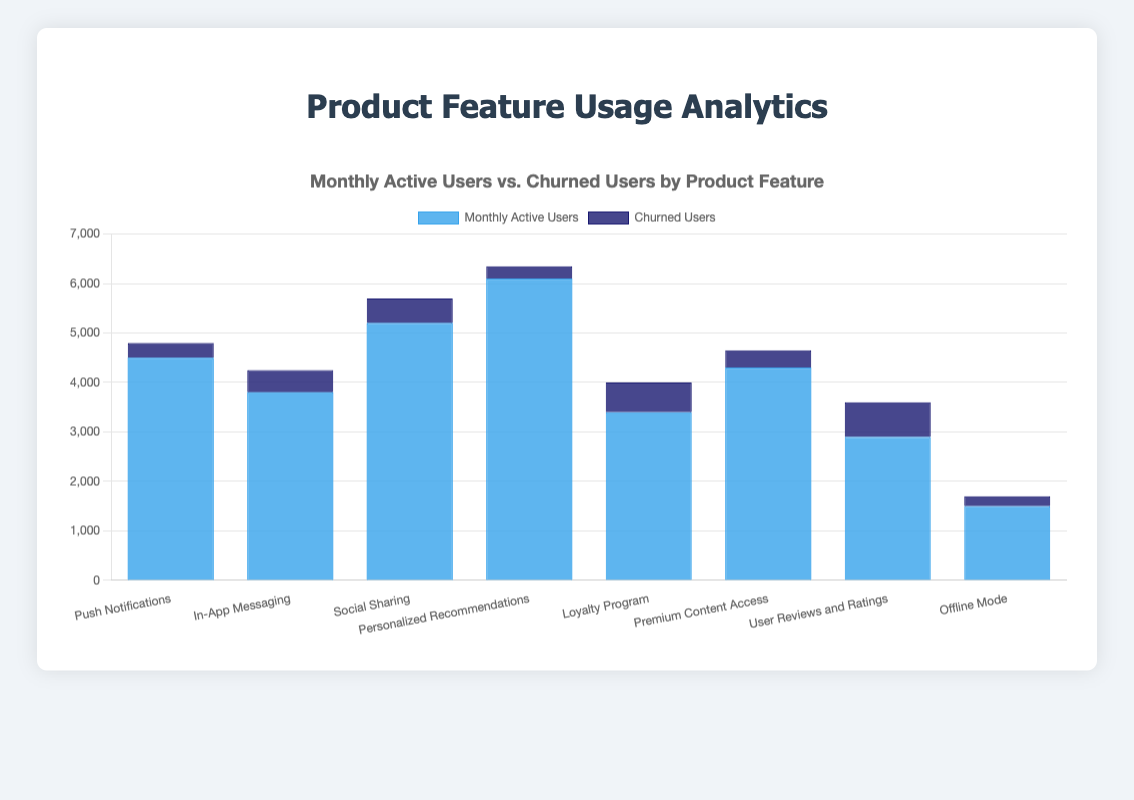Which feature has the highest number of Monthly Active Users? The feature with the highest bar in the dataset is Personalized Recommendations, which has 6,100 Monthly Active Users.
Answer: Personalized Recommendations What is the difference in Monthly Active Users between Social Sharing and In-App Messaging? Social Sharing has 5,200 Monthly Active Users and In-App Messaging has 3,800. The difference is 5,200 - 3,800 = 1,400.
Answer: 1,400 Which feature has the lowest churn rate? (Churn rate = Churned Users / Monthly Active Users) To find the churn rate, calculate the ratio for each feature and compare. Personalized Recommendations has 250 churned users and 6,100 active users, 250/6100 ≈ 0.041 (4.1%), which is the lowest among all features.
Answer: Personalized Recommendations How many features have more than 400 churned users? By observing the data, In-App Messaging (450), Social Sharing (500), Loyalty Program (600), and User Reviews and Ratings (700) have more than 400 churned users. There are 4 features in total.
Answer: 4 Which feature has the highest churn rate? To find the highest churn rate, calculate the ratio for each feature and compare. User Reviews and Ratings has 700 churned users and 2,900 active users, 700/2900 ≈ 0.241 (24.1%), which is the highest among all features.
Answer: User Reviews and Ratings What is the total number of Monthly Active Users across all features? Sum of Monthly Active Users: 4500 + 3800 + 5200 + 6100 + 3400 + 4300 + 2900 + 1500 = 31,700.
Answer: 31,700 Compare the churned users of Push Notifications and Premium Content Access, which has more? Push Notifications has 300 churned users, and Premium Content Access has 350 churned users, so Premium Content Access has more churned users.
Answer: Premium Content Access What is the average number of Monthly Active Users per feature? Sum of Monthly Active Users is 31,700. There are 8 features, so the average is 31,700 / 8 = 3,962.5.
Answer: 3,962.5 Which feature has the lowest number of Monthly Active Users? The feature with the lowest bar representing Monthly Active Users is Offline Mode, with 1,500 users.
Answer: Offline Mode 